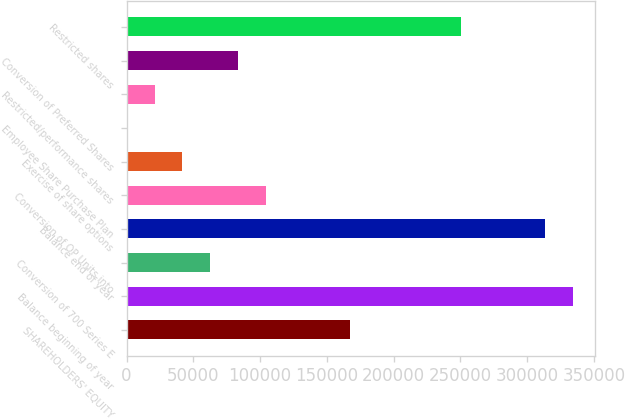Convert chart to OTSL. <chart><loc_0><loc_0><loc_500><loc_500><bar_chart><fcel>SHAREHOLDERS' EQUITY<fcel>Balance beginning of year<fcel>Conversion of 700 Series E<fcel>Balance end of year<fcel>Conversion of OP Units into<fcel>Exercise of share options<fcel>Employee Share Purchase Plan<fcel>Restricted/performance shares<fcel>Conversion of Preferred Shares<fcel>Restricted shares<nl><fcel>167029<fcel>334056<fcel>62637.9<fcel>313178<fcel>104394<fcel>41759.6<fcel>3<fcel>20881.3<fcel>83516.2<fcel>250543<nl></chart> 